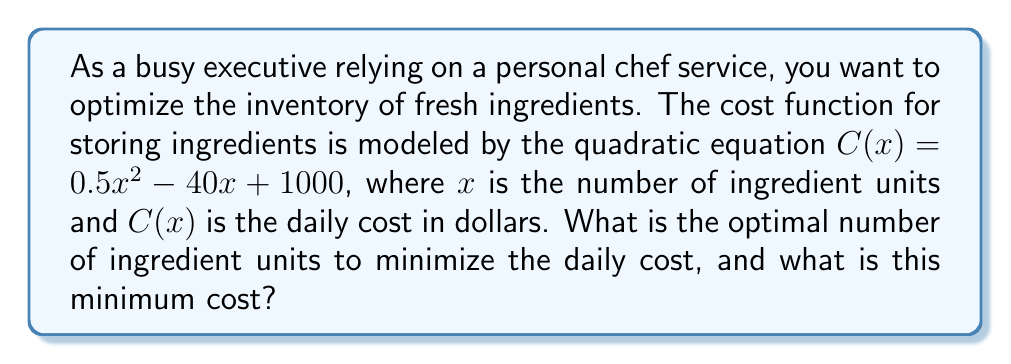Can you solve this math problem? To find the optimal number of ingredient units and the minimum cost, we need to follow these steps:

1) The cost function is a quadratic equation in the form $C(x) = ax^2 + bx + c$, where:
   $a = 0.5$
   $b = -40$
   $c = 1000$

2) For a quadratic function, the minimum (or maximum) occurs at the vertex of the parabola. The x-coordinate of the vertex is given by the formula $x = -\frac{b}{2a}$

3) Let's calculate the x-coordinate of the vertex:
   $x = -\frac{b}{2a} = -\frac{-40}{2(0.5)} = \frac{40}{1} = 40$

4) This means the optimal number of ingredient units is 40.

5) To find the minimum cost, we need to calculate $C(40)$:
   $C(40) = 0.5(40)^2 - 40(40) + 1000$
   $= 0.5(1600) - 1600 + 1000$
   $= 800 - 1600 + 1000$
   $= 200$

Therefore, the optimal number of ingredient units is 40, and the minimum daily cost is $200.
Answer: 40 units; $200 